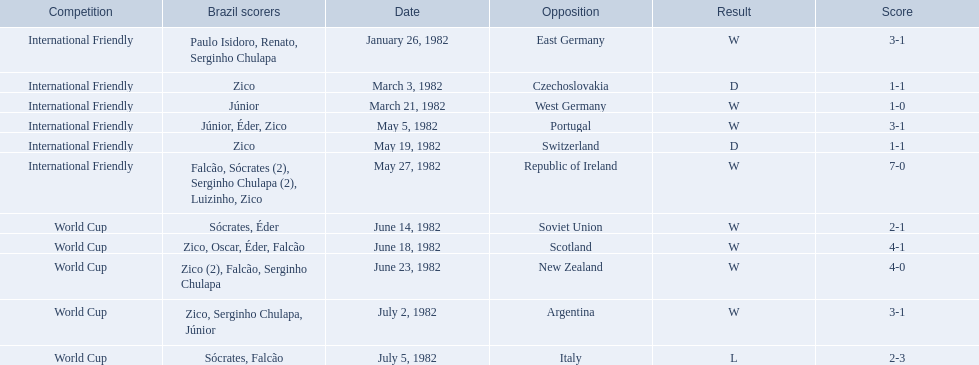What are all the dates of games in 1982 in brazilian football? January 26, 1982, March 3, 1982, March 21, 1982, May 5, 1982, May 19, 1982, May 27, 1982, June 14, 1982, June 18, 1982, June 23, 1982, July 2, 1982, July 5, 1982. Which of these dates is at the top of the chart? January 26, 1982. 